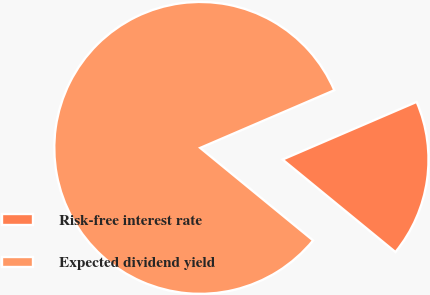Convert chart. <chart><loc_0><loc_0><loc_500><loc_500><pie_chart><fcel>Risk-free interest rate<fcel>Expected dividend yield<nl><fcel>17.39%<fcel>82.61%<nl></chart> 